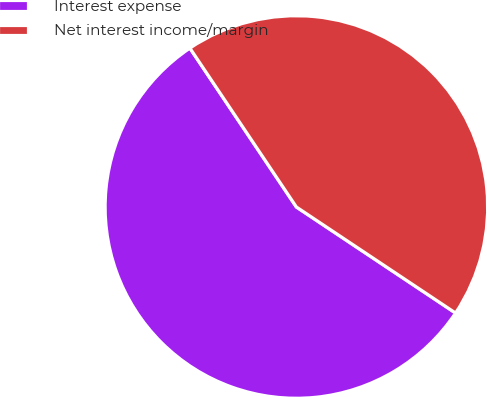Convert chart. <chart><loc_0><loc_0><loc_500><loc_500><pie_chart><fcel>Interest expense<fcel>Net interest income/margin<nl><fcel>56.25%<fcel>43.75%<nl></chart> 